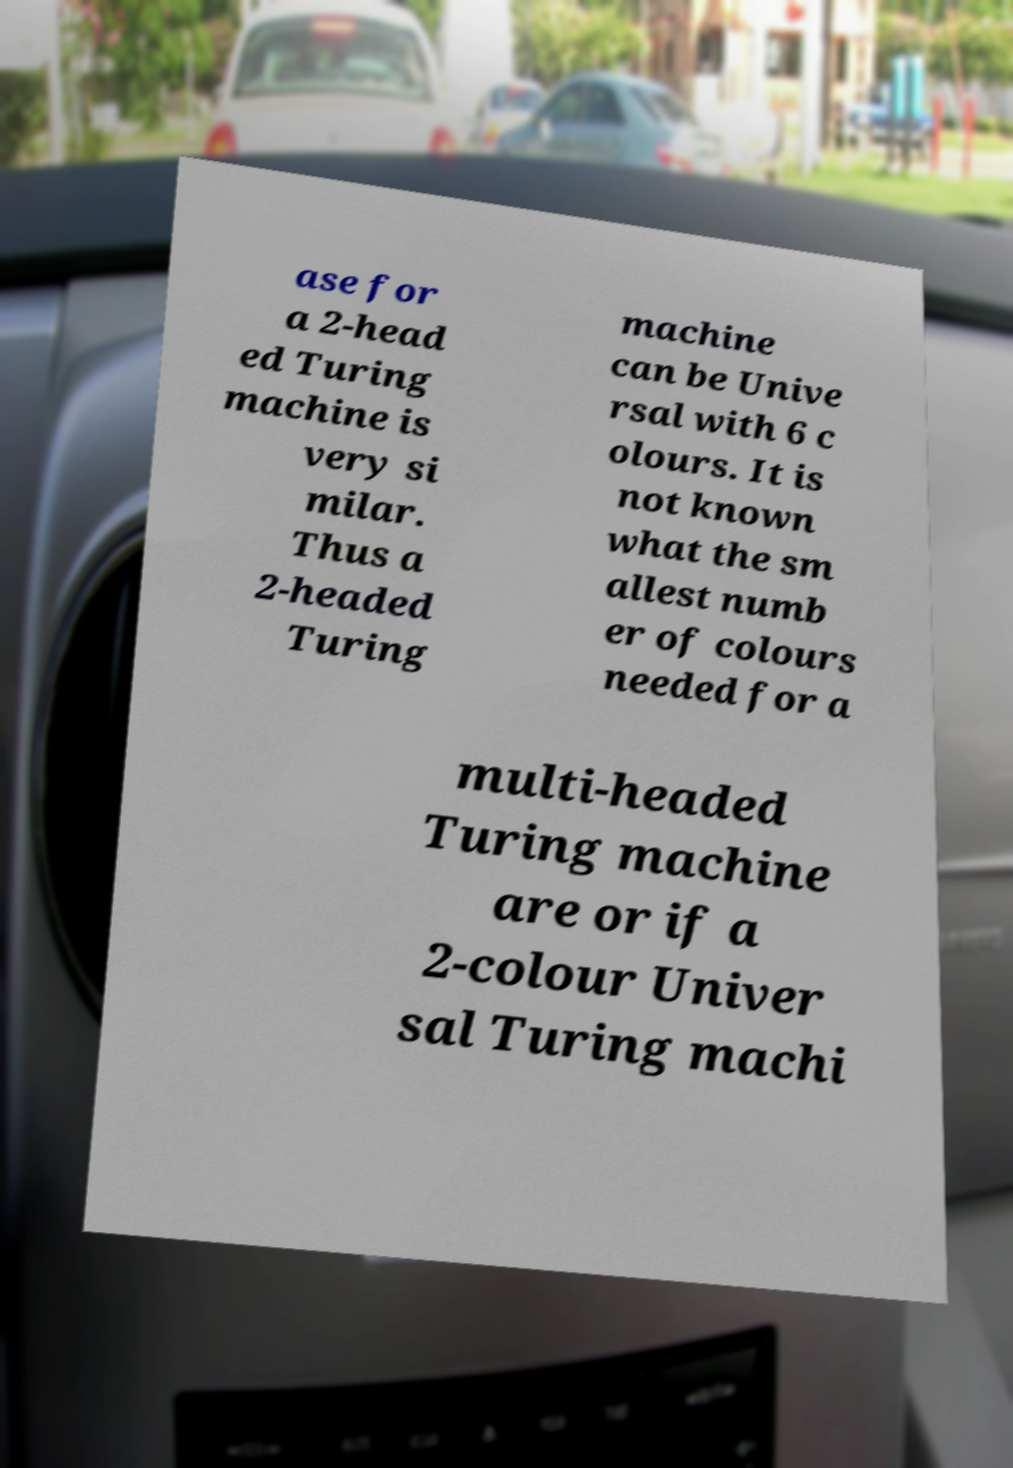Could you assist in decoding the text presented in this image and type it out clearly? ase for a 2-head ed Turing machine is very si milar. Thus a 2-headed Turing machine can be Unive rsal with 6 c olours. It is not known what the sm allest numb er of colours needed for a multi-headed Turing machine are or if a 2-colour Univer sal Turing machi 